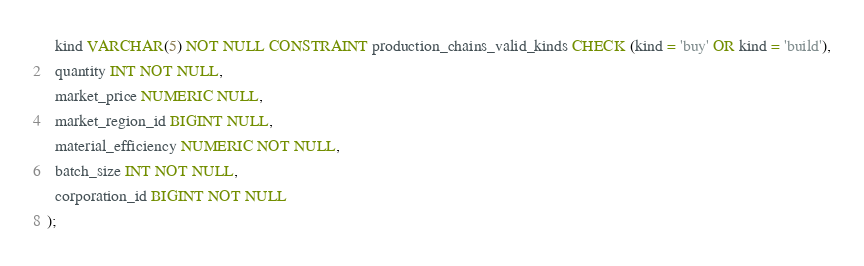Convert code to text. <code><loc_0><loc_0><loc_500><loc_500><_SQL_>  kind VARCHAR(5) NOT NULL CONSTRAINT production_chains_valid_kinds CHECK (kind = 'buy' OR kind = 'build'),
  quantity INT NOT NULL,
  market_price NUMERIC NULL,
  market_region_id BIGINT NULL,
  material_efficiency NUMERIC NOT NULL,
  batch_size INT NOT NULL,
  corporation_id BIGINT NOT NULL
);
</code> 